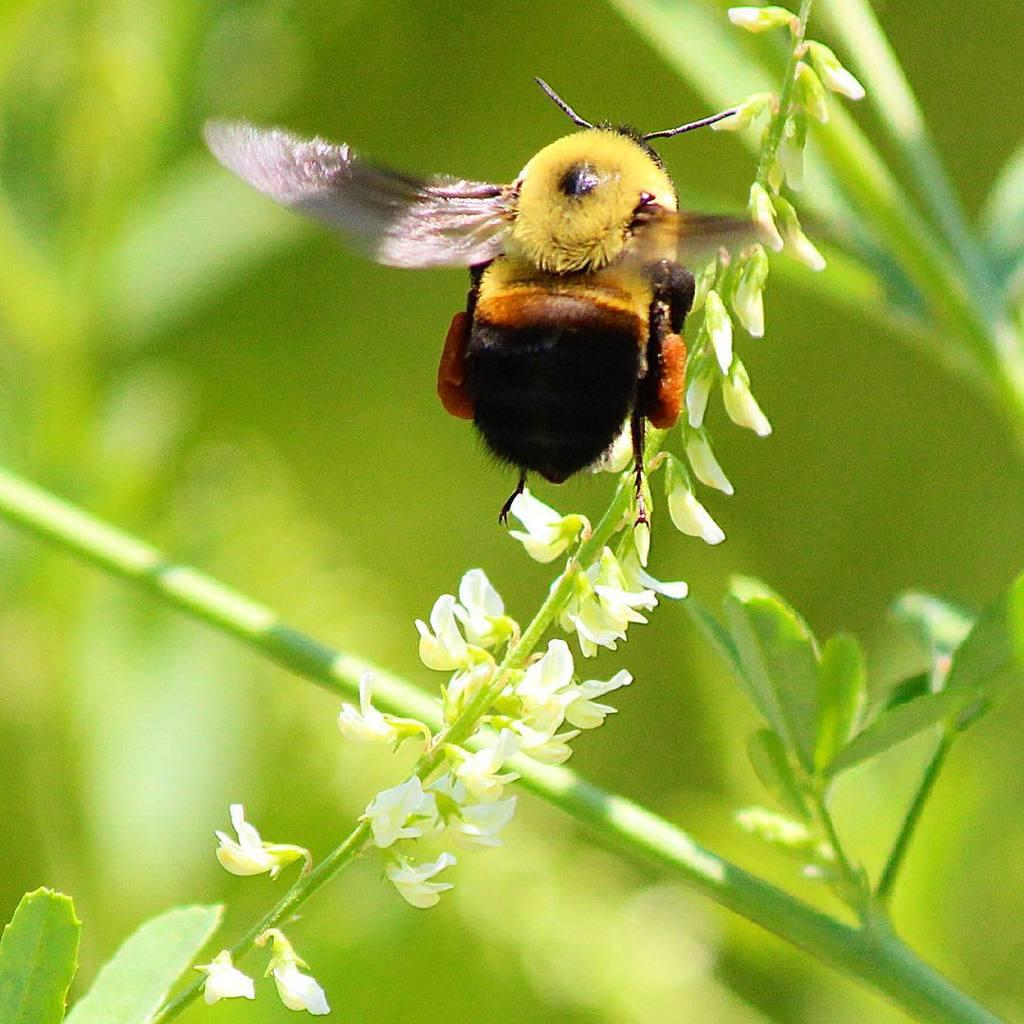What is flying in the image? There is an insect flying in the image. What type of plant can be seen in the image? There is a plant with tiny flowers and leaves in the image. What part of the plant supports the flowers and leaves? The plant has a stem. What color is predominant in the background of the image? The background of the image appears green in color. What type of jam is being spread on the plant in the image? There is no jam or spreading activity present in the image; it features an insect and a plant. 